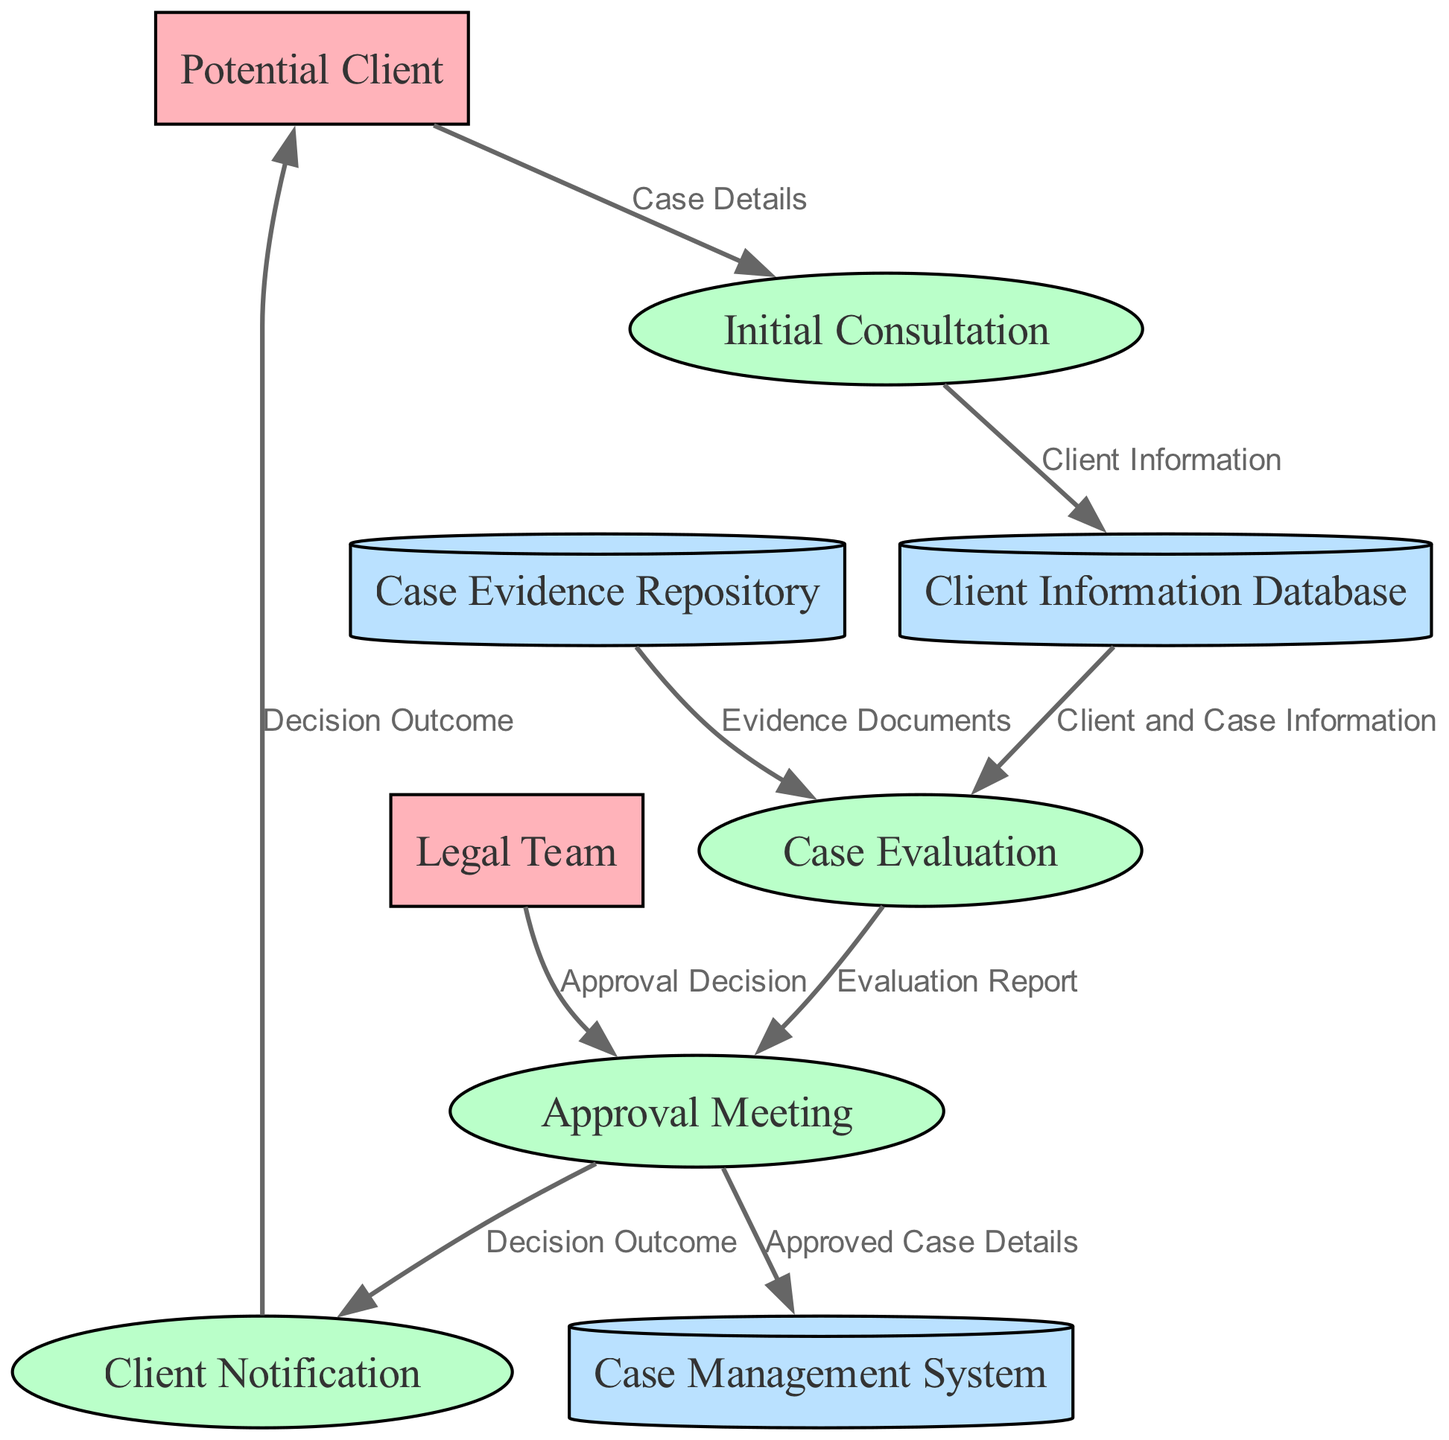What is the name of the first process in the diagram? The first process in the diagram is "Initial Consultation", which is the beginning step where the lawyer discusses the case with the potential client.
Answer: Initial Consultation How many external entities are present in the diagram? There are two external entities: "Potential Client" and "Legal Team".
Answer: 2 What type of data flow occurs from the "Initial Consultation" to "Client Information Database"? The data flow from "Initial Consultation" to "Client Information Database" is labeled "Client Information". This indicates that information gathered during the consultation is stored in the database.
Answer: Client Information Which process receives data from both "Client Information Database" and "Case Evidence Repository"? The "Case Evaluation" process receives data from both "Client Information Database" (Client and Case Information) and "Case Evidence Repository" (Evidence Documents), allowing the lawyer to assess the merits of the case.
Answer: Case Evaluation What is the final process that communicates the decision outcome to the potential client? The final process is "Client Notification", which informs the potential client about the decision made regarding their case.
Answer: Client Notification Which data store holds documents and evidence related to the case? The "Case Evidence Repository" is the data store that holds documents, photos, medical reports, and other evidence pertaining to the case.
Answer: Case Evidence Repository How many processes are involved from the initial consultation to the client notification? There are four processes: "Initial Consultation", "Case Evaluation", "Approval Meeting", and "Client Notification", indicating the workflow from beginning to end of the case evaluation process.
Answer: 4 What does the "Approval Meeting" process evaluate? The "Approval Meeting" process evaluates the "Evaluation Report" created during the case evaluation to decide on taking the case.
Answer: Evaluation Report 